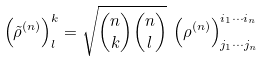Convert formula to latex. <formula><loc_0><loc_0><loc_500><loc_500>\left ( \tilde { \rho } ^ { ( n ) } \right ) ^ { k } _ { l } = \sqrt { { n \choose k } { n \choose l } } \, \left ( \rho ^ { ( n ) } \right ) ^ { i _ { 1 } \cdots i _ { n } } _ { j _ { 1 } \cdots j _ { n } }</formula> 